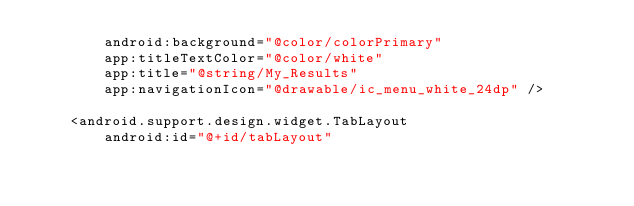<code> <loc_0><loc_0><loc_500><loc_500><_XML_>        android:background="@color/colorPrimary"
        app:titleTextColor="@color/white"
        app:title="@string/My_Results"
        app:navigationIcon="@drawable/ic_menu_white_24dp" />

    <android.support.design.widget.TabLayout
        android:id="@+id/tabLayout"</code> 